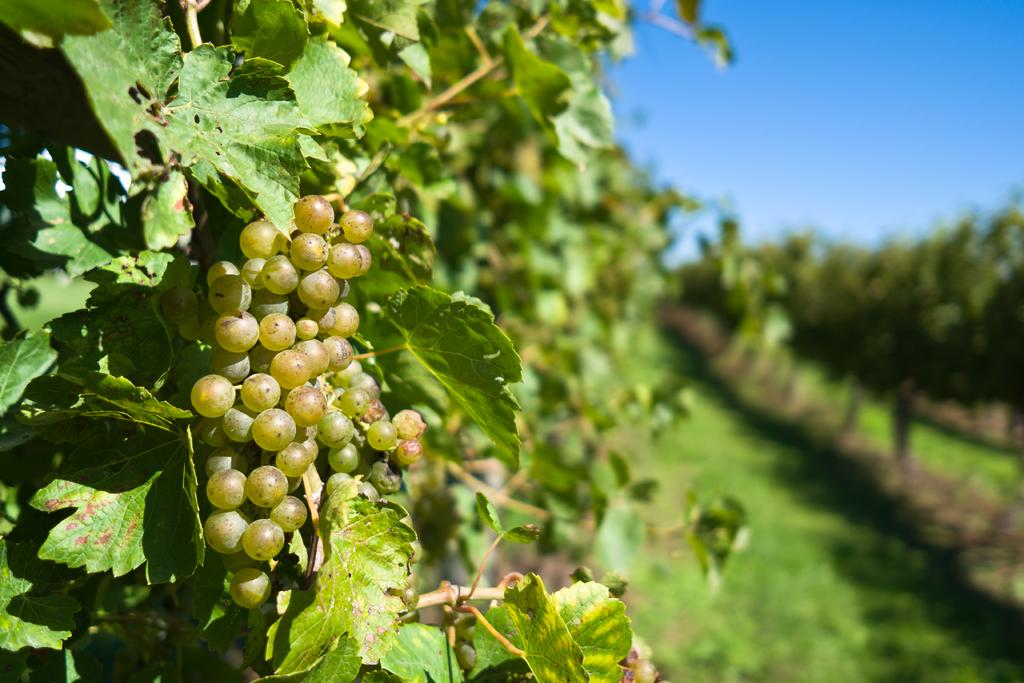What type of vegetation can be seen in the image? There are trees in the image. What is the color of the trees? The trees are green in color. What fruit can be seen on the trees? There are grapes on the trees. What else is visible in the image besides the trees? The sky is visible in the image. Is it quiet in the image? The concept of "quiet" cannot be determined from the image, as it only shows trees and grapes. Can you see a chair in the image? There is no chair present in the image. 